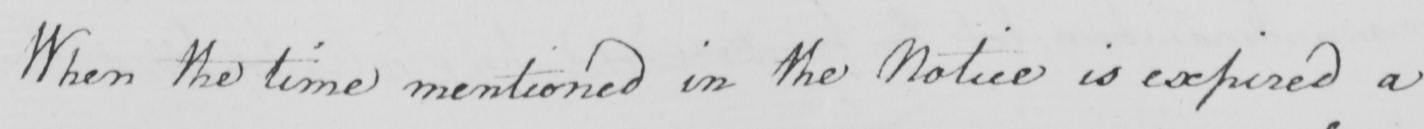Please provide the text content of this handwritten line. When the time mentioned in the Notice is expired a 